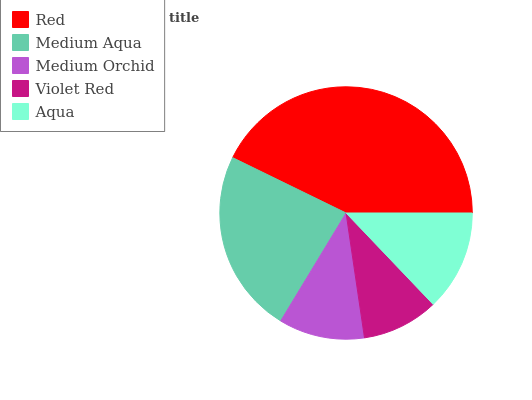Is Violet Red the minimum?
Answer yes or no. Yes. Is Red the maximum?
Answer yes or no. Yes. Is Medium Aqua the minimum?
Answer yes or no. No. Is Medium Aqua the maximum?
Answer yes or no. No. Is Red greater than Medium Aqua?
Answer yes or no. Yes. Is Medium Aqua less than Red?
Answer yes or no. Yes. Is Medium Aqua greater than Red?
Answer yes or no. No. Is Red less than Medium Aqua?
Answer yes or no. No. Is Aqua the high median?
Answer yes or no. Yes. Is Aqua the low median?
Answer yes or no. Yes. Is Violet Red the high median?
Answer yes or no. No. Is Violet Red the low median?
Answer yes or no. No. 